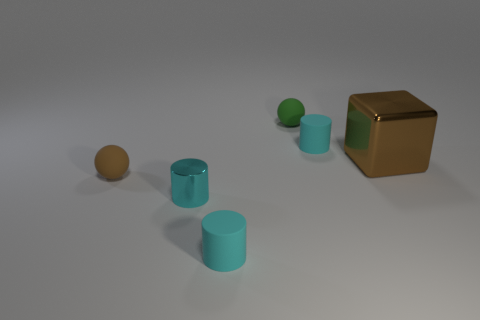There is a small rubber cylinder in front of the brown cube; are there any balls on the left side of it? Upon inspecting the image closely, there appears to be one ball to the left side of the brown cube, which has a tan or light brown color. It is situated near the edge of the frame, maintaining a clear gap between itself and the cube. 